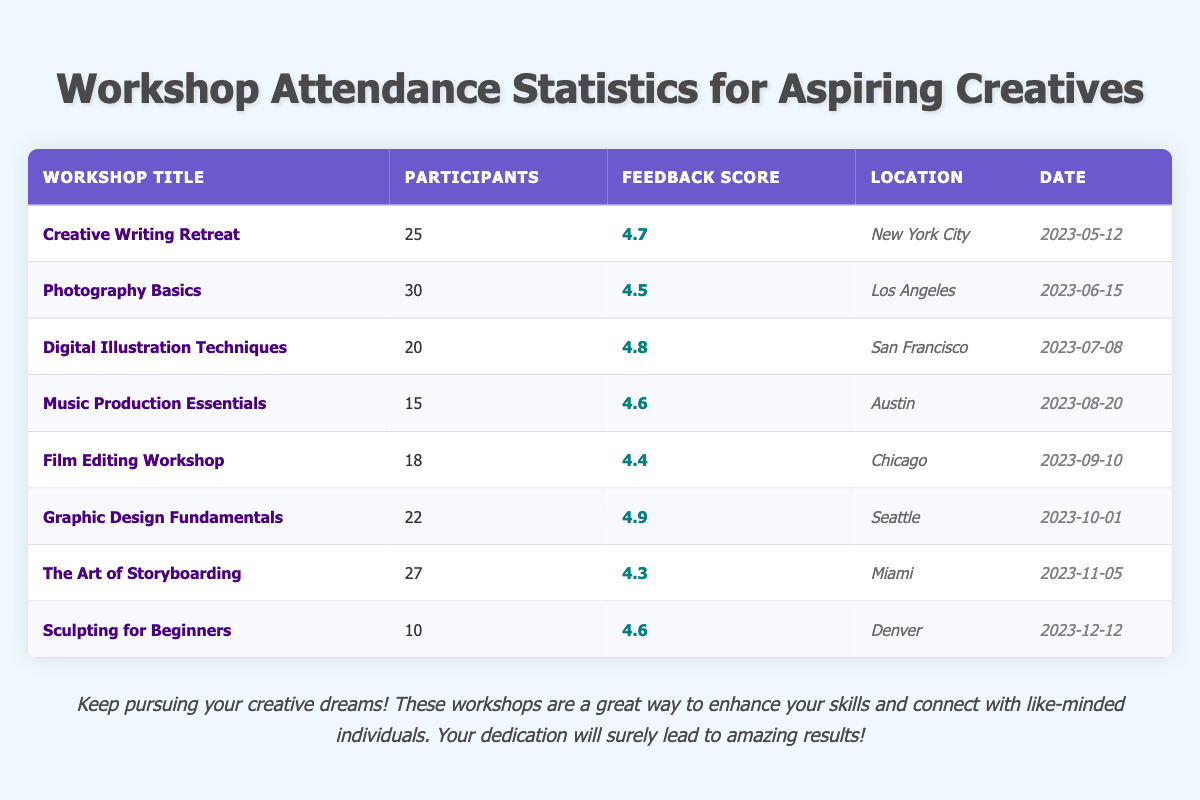What is the highest feedback score among the workshops? The feedback scores listed in the table are 4.7, 4.5, 4.8, 4.6, 4.4, 4.9, 4.3, and 4.6. The highest value among these is 4.9.
Answer: 4.9 Which workshop had the least number of participants? The participant counts in the table are 25, 30, 20, 15, 18, 22, 27, and 10. The smallest value is 10 from "Sculpting for Beginners."
Answer: 10 What is the total number of participants across all workshops? Adding up all the participant counts: 25 + 30 + 20 + 15 + 18 + 22 + 27 + 10 =  167.
Answer: 167 Did any workshop take place in Miami? The table shows that "The Art of Storyboarding" workshop is located in Miami, confirming that there is indeed a workshop there.
Answer: Yes What is the average feedback score of all workshops? The feedback scores are 4.7, 4.5, 4.8, 4.6, 4.4, 4.9, 4.3, and 4.6. Adding these gives 4.7 + 4.5 + 4.8 + 4.6 + 4.4 + 4.9 + 4.3 + 4.6 = 36.8. Dividing by 8 (since there are 8 workshops) gives 36.8 / 8 = 4.6.
Answer: 4.6 Which workshop had the highest number of participants, and how many were there? Referring to the participant counts, "Photography Basics" had the highest count of 30 participants.
Answer: 30 Which two workshops were held in the same month? The table shows that "Music Production Essentials" was in August and "Film Editing Workshop" was in September. No workshops were held in the same month.
Answer: No How many workshops received a feedback score of 4.6 or higher? The feedback scores of 4.6 or above are 4.7, 4.8, 4.6, 4.9, and 4.6. Counting these, there are 5 workshops meeting this criterion.
Answer: 5 What two locations had the highest feedback scores and what were those scores? The feedback scores for Seattle and San Francisco are the highest at 4.9 and 4.8 respectively.
Answer: Seattle: 4.9, San Francisco: 4.8 Which workshop occurred most recently, and when was it held? The most recent date in the table is "2023-12-12," which corresponds to "Sculpting for Beginners."
Answer: Sculpting for Beginners, 2023-12-12 